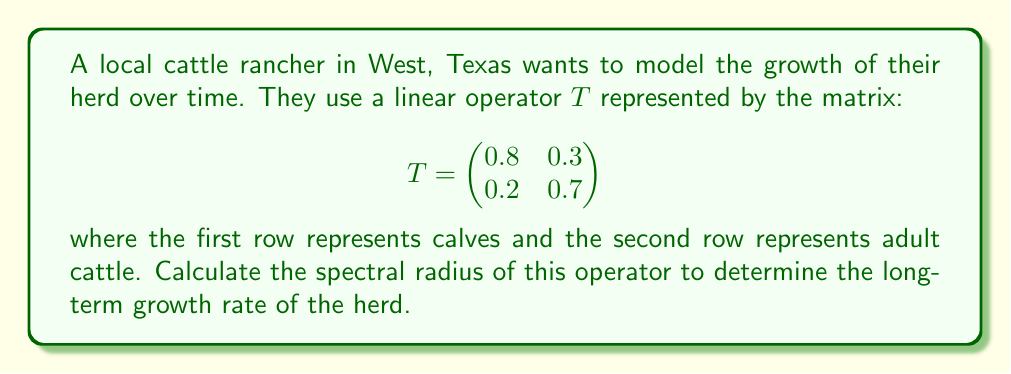Could you help me with this problem? To find the spectral radius of the linear operator $T$, we need to follow these steps:

1) First, calculate the eigenvalues of $T$. The characteristic equation is:

   $$\det(T - \lambda I) = \begin{vmatrix}
   0.8 - \lambda & 0.3 \\
   0.2 & 0.7 - \lambda
   \end{vmatrix} = 0$$

2) Expand the determinant:

   $$(0.8 - \lambda)(0.7 - \lambda) - 0.3 \cdot 0.2 = 0$$
   $$\lambda^2 - 1.5\lambda + 0.5 = 0$$

3) Solve this quadratic equation:

   $$\lambda = \frac{1.5 \pm \sqrt{1.5^2 - 4(0.5)}}{2} = \frac{1.5 \pm \sqrt{1.25}}{2}$$

4) This gives us two eigenvalues:

   $$\lambda_1 = \frac{1.5 + \sqrt{1.25}}{2} \approx 1.0590$$
   $$\lambda_2 = \frac{1.5 - \sqrt{1.25}}{2} \approx 0.4410$$

5) The spectral radius is the maximum absolute value of the eigenvalues:

   $$\rho(T) = \max(|\lambda_1|, |\lambda_2|) = |\lambda_1| \approx 1.0590$$
Answer: $1.0590$ 